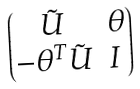Convert formula to latex. <formula><loc_0><loc_0><loc_500><loc_500>\begin{pmatrix} \tilde { U } & \theta \\ - \theta ^ { T } \tilde { U } & I \, \end{pmatrix}</formula> 